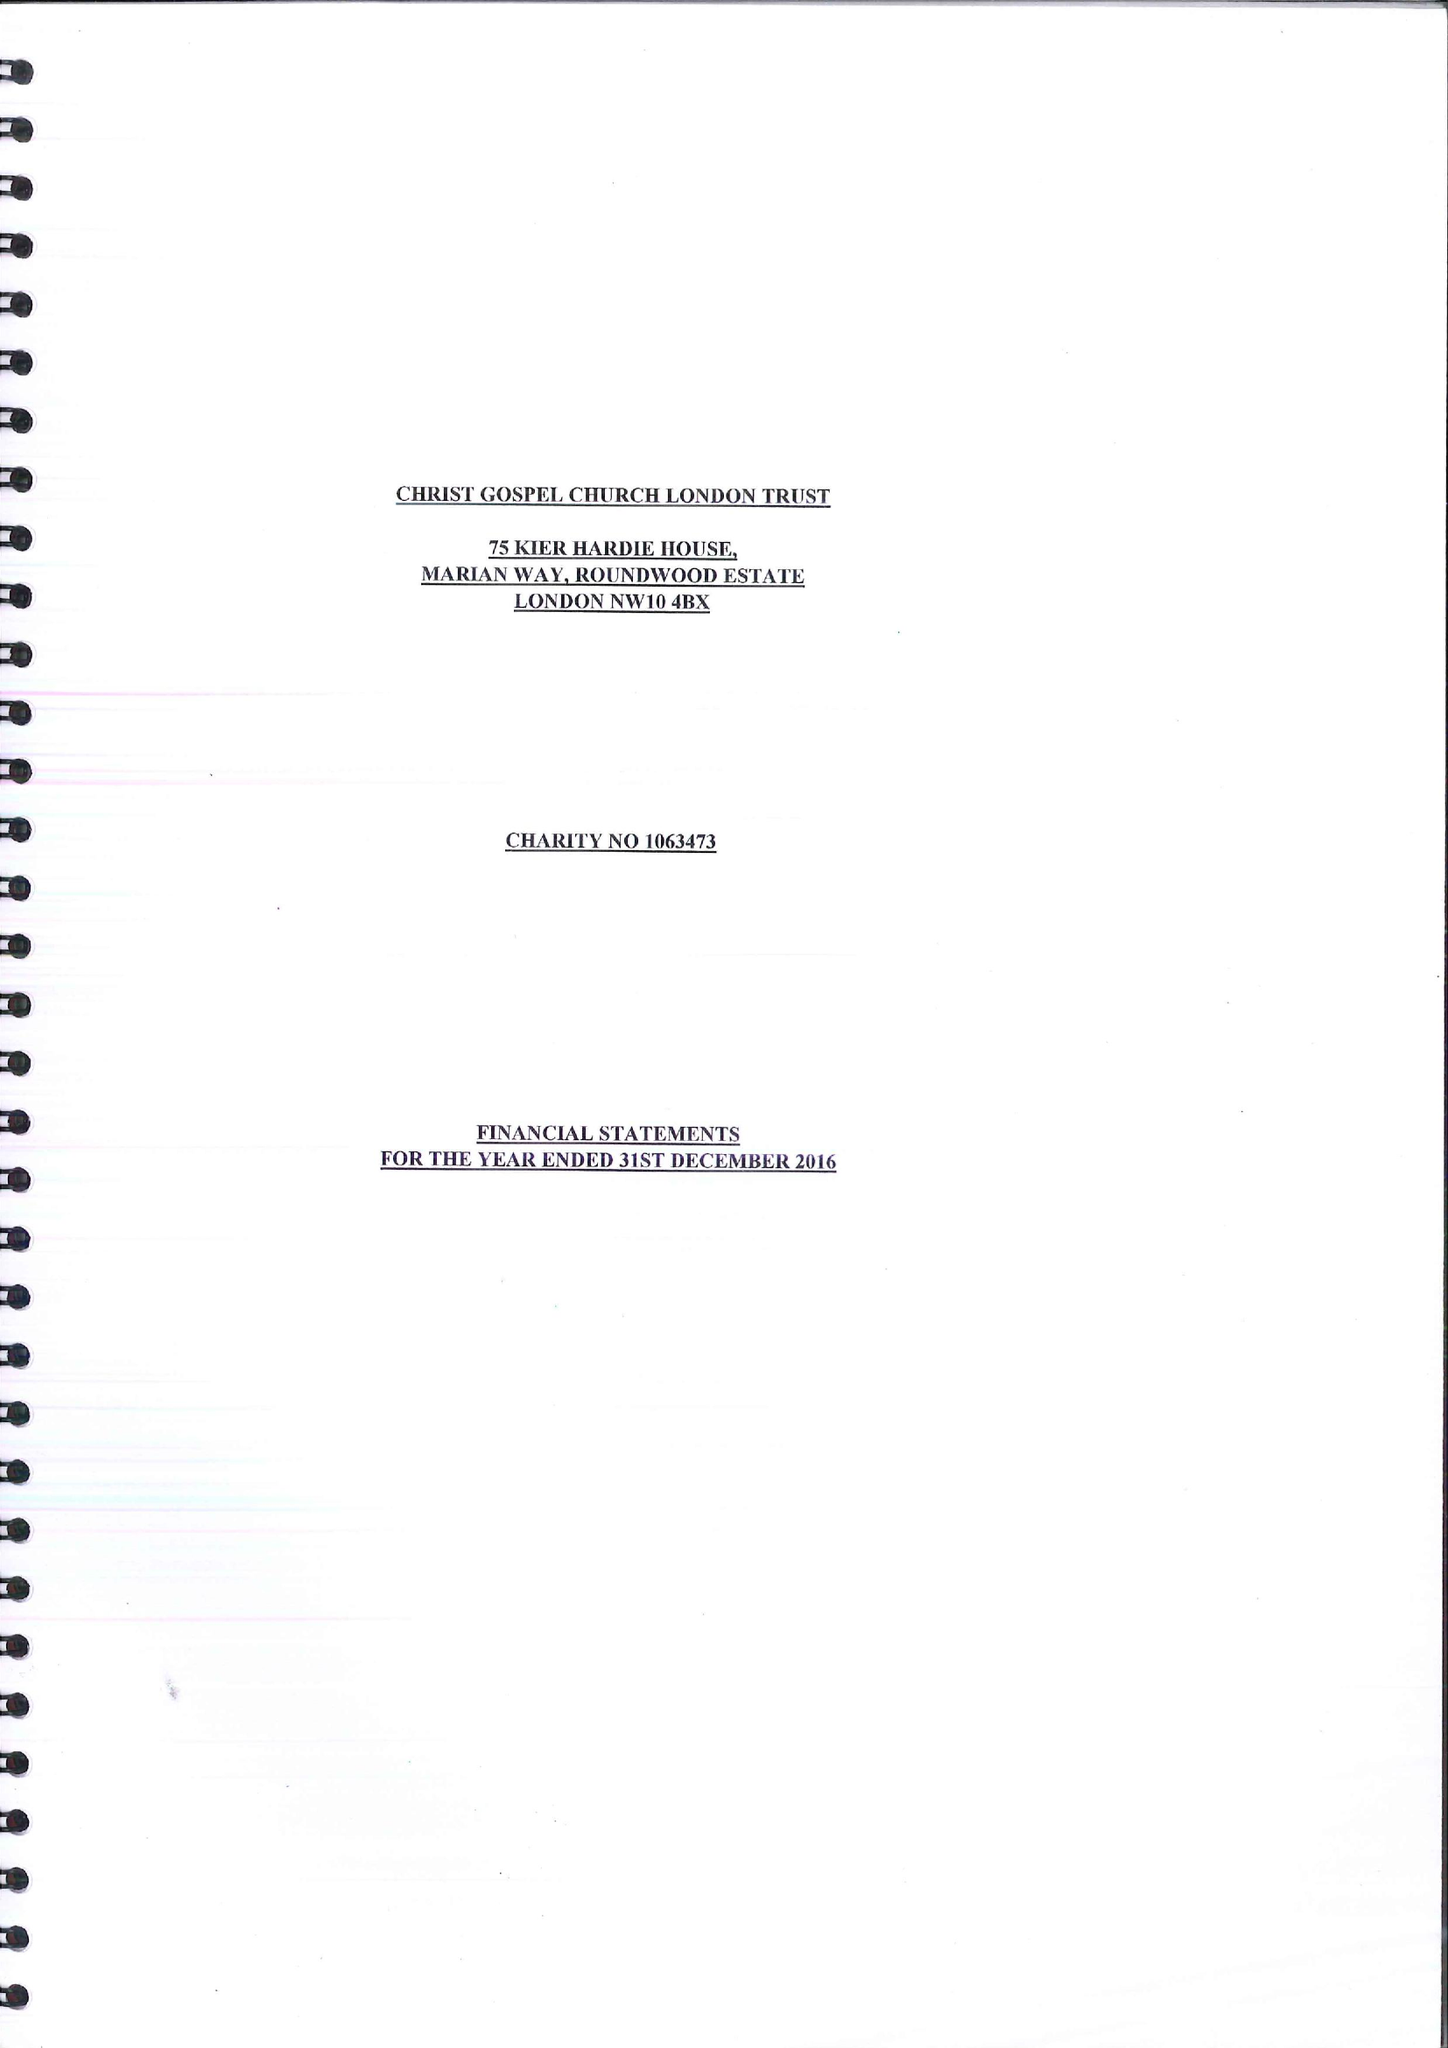What is the value for the report_date?
Answer the question using a single word or phrase. 2016-12-31 